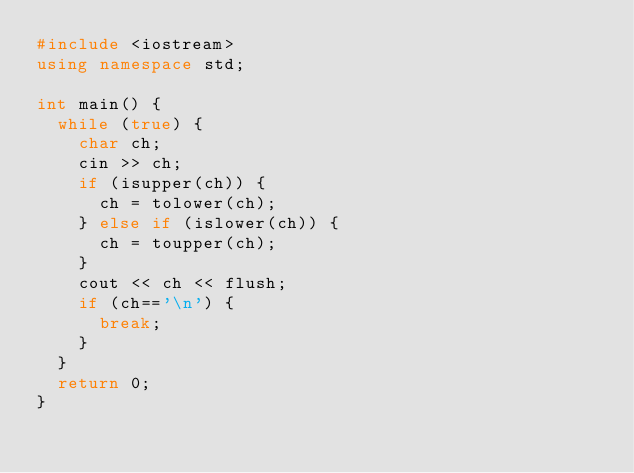<code> <loc_0><loc_0><loc_500><loc_500><_C++_>#include <iostream>                                                  
using namespace std;                                                 
                                                                     
int main() {                                                         
  while (true) {                                                     
    char ch;                                                         
    cin >> ch;                                                       
    if (isupper(ch)) {                                               
      ch = tolower(ch);                                              
    } else if (islower(ch)) {                                        
      ch = toupper(ch);                                              
    }                                                                
    cout << ch << flush;                                             
    if (ch=='\n') {                                                  
      break;                                                         
    }                                                                
  }                                                                  
  return 0;                                                          
}                                                                    
                                                                     
                                                                     
       </code> 